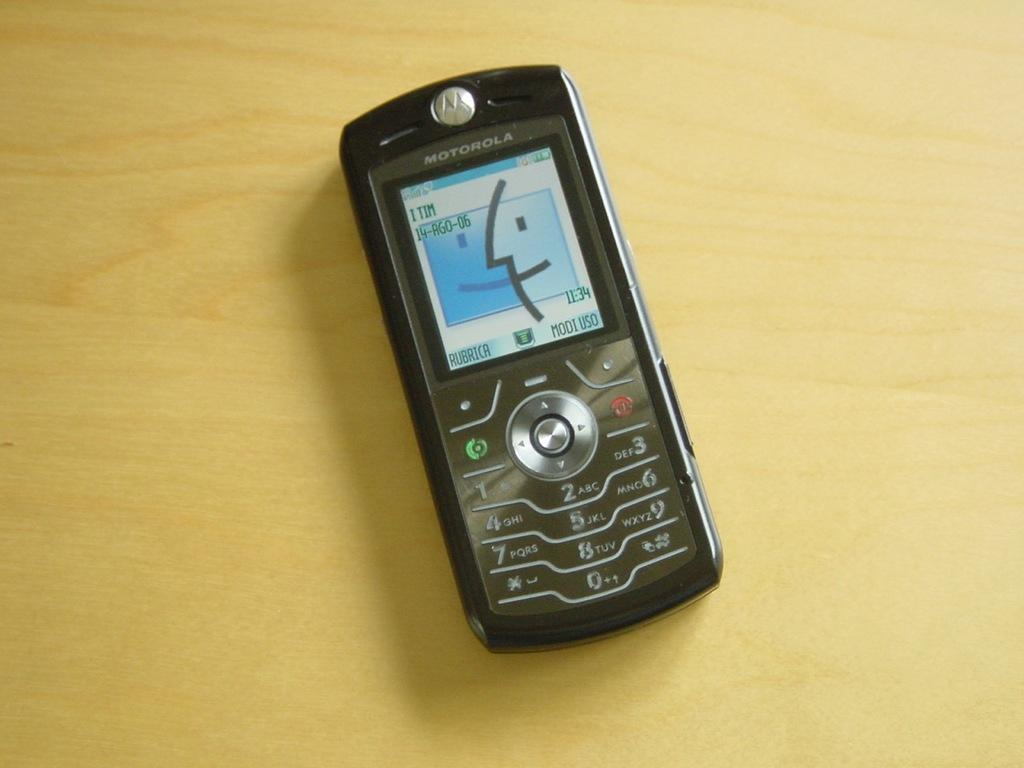<image>
Relay a brief, clear account of the picture shown. A Motorola cell phone that the screen says I TIM in the corner. 